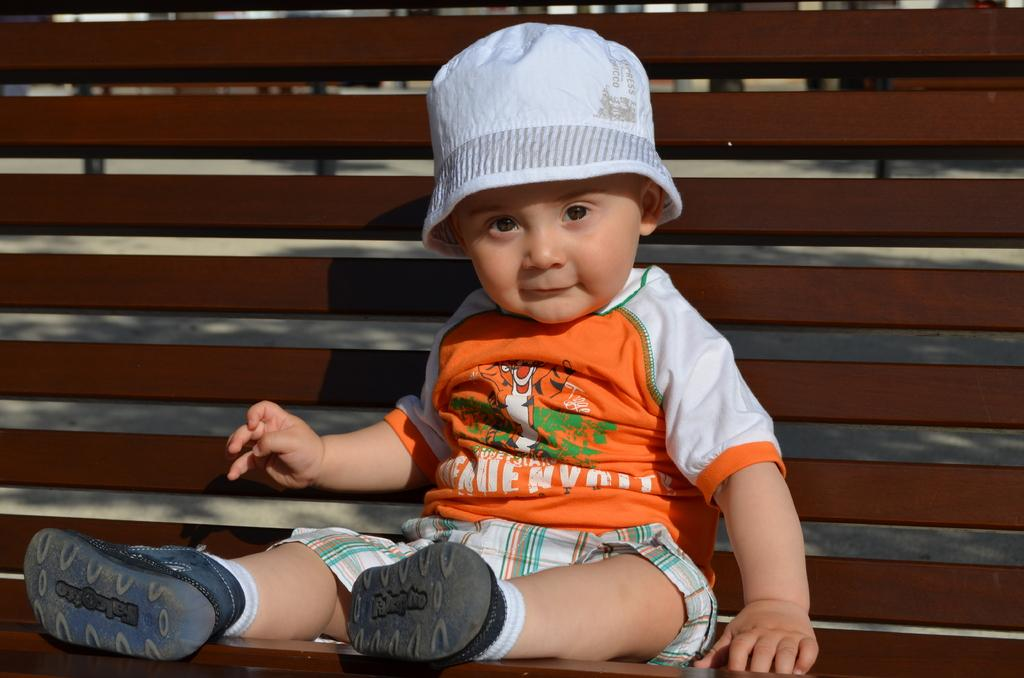What is the main subject of the image? The main subject of the image is a kid. What is the kid wearing in the image? The kid is wearing a hat in the image. What is the kid doing in the image? The kid is sitting on a bench in the image. What is the relation between the hour and the neck in the image? There is no hour or neck mentioned in the image; it only features a kid wearing a hat and sitting on a bench. 